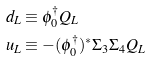Convert formula to latex. <formula><loc_0><loc_0><loc_500><loc_500>d _ { L } & \equiv \phi _ { 0 } ^ { \dagger } Q _ { L } \\ u _ { L } & \equiv - ( \phi _ { 0 } ^ { \dagger } ) ^ { * } \Sigma _ { 3 } \Sigma _ { 4 } Q _ { L }</formula> 